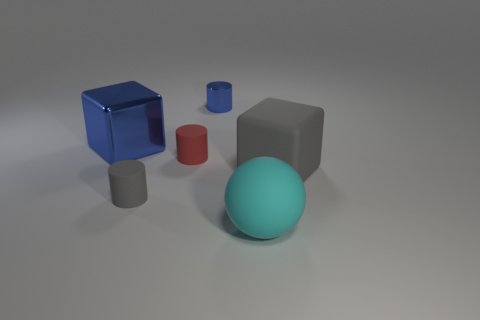Is the number of balls that are behind the red cylinder less than the number of large gray rubber cubes?
Your answer should be compact. Yes. What is the material of the tiny cylinder that is to the right of the red thing?
Keep it short and to the point. Metal. How many other things are the same size as the red rubber cylinder?
Provide a succinct answer. 2. Are there fewer cyan objects than tiny brown metal balls?
Offer a very short reply. No. There is a red matte object; what shape is it?
Your answer should be very brief. Cylinder. Is the color of the block that is in front of the large blue metal object the same as the large metal thing?
Offer a terse response. No. What is the shape of the object that is both to the left of the red rubber cylinder and behind the gray rubber cylinder?
Provide a succinct answer. Cube. What is the color of the small rubber object that is behind the large gray matte cube?
Keep it short and to the point. Red. Is there anything else that has the same color as the tiny shiny object?
Offer a very short reply. Yes. Is the size of the gray block the same as the red matte thing?
Ensure brevity in your answer.  No. 